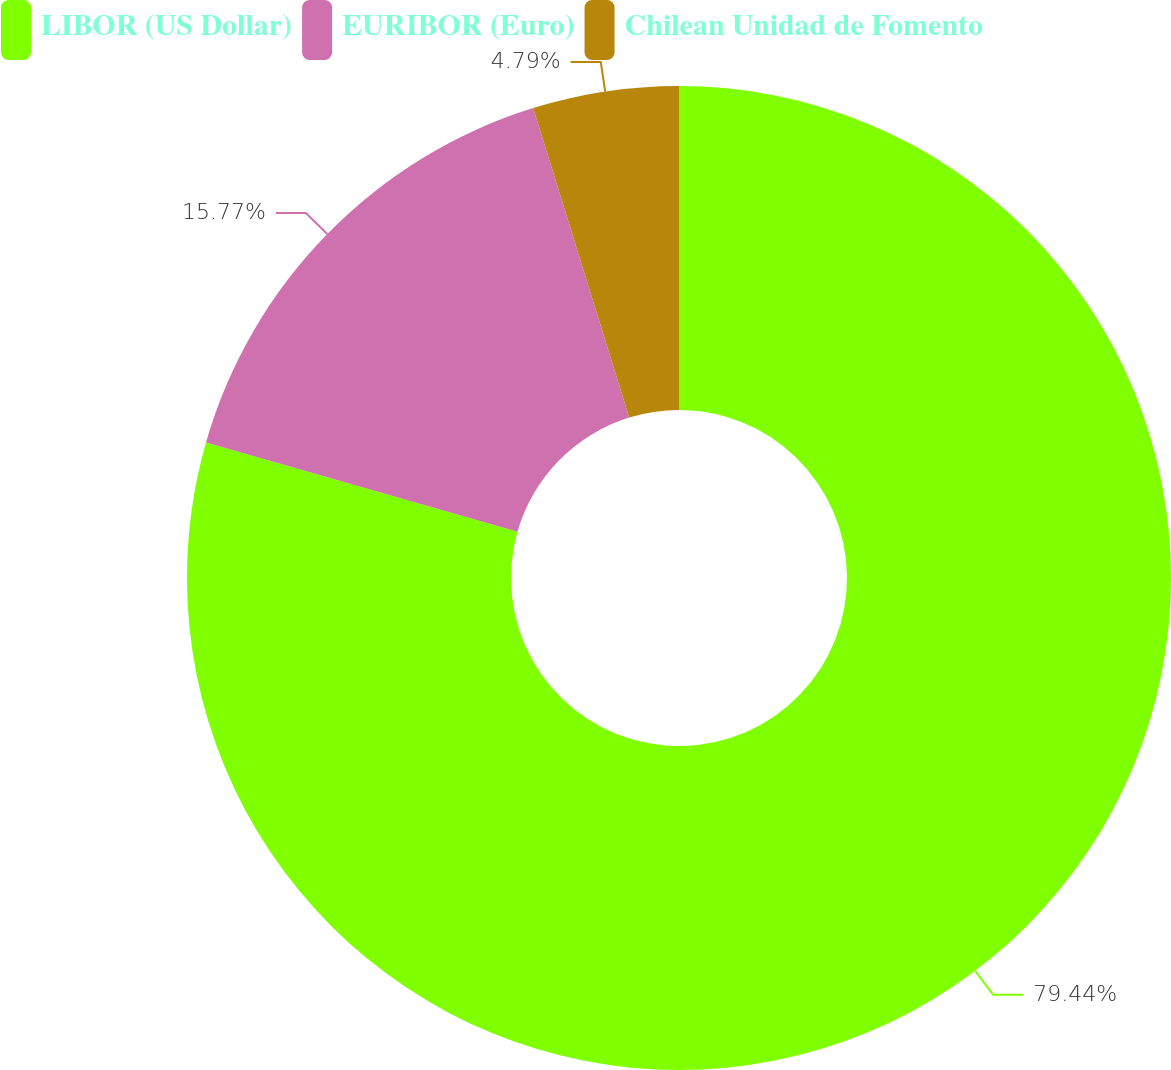Convert chart to OTSL. <chart><loc_0><loc_0><loc_500><loc_500><pie_chart><fcel>LIBOR (US Dollar)<fcel>EURIBOR (Euro)<fcel>Chilean Unidad de Fomento<nl><fcel>79.44%<fcel>15.77%<fcel>4.79%<nl></chart> 